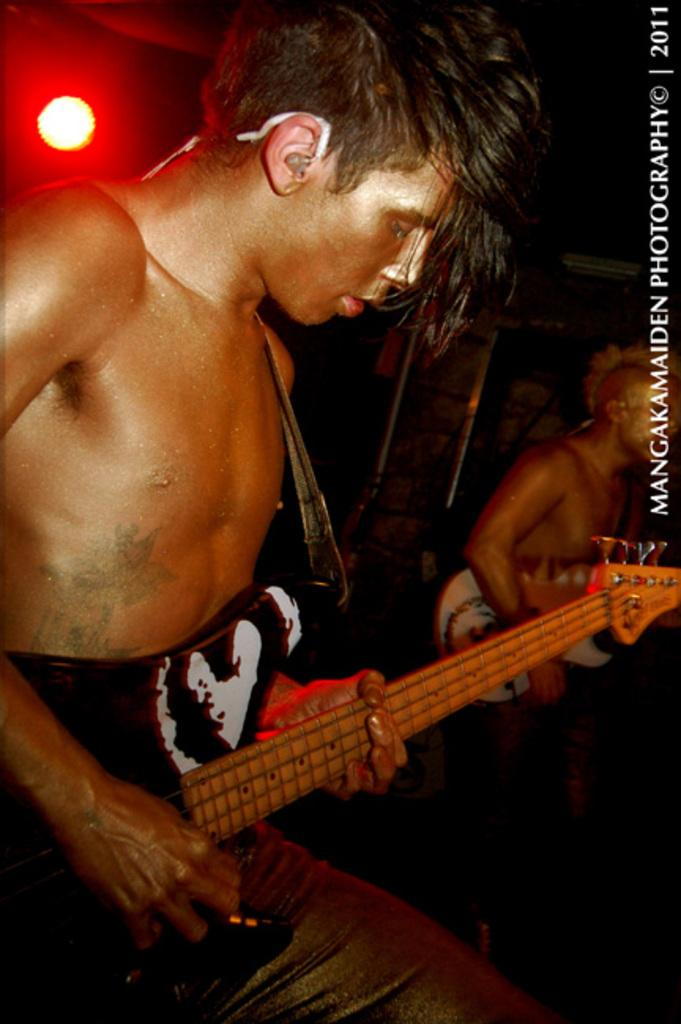How many people are in the image? There are two men in the image. What are the men holding in the image? Both men are holding guitars. Can you describe the lighting in the background of the image? There is a red color light in the background of the image. What type of marble is being used to play the guitar in the image? There is no marble present in the image, and the guitars are not made of marble. 